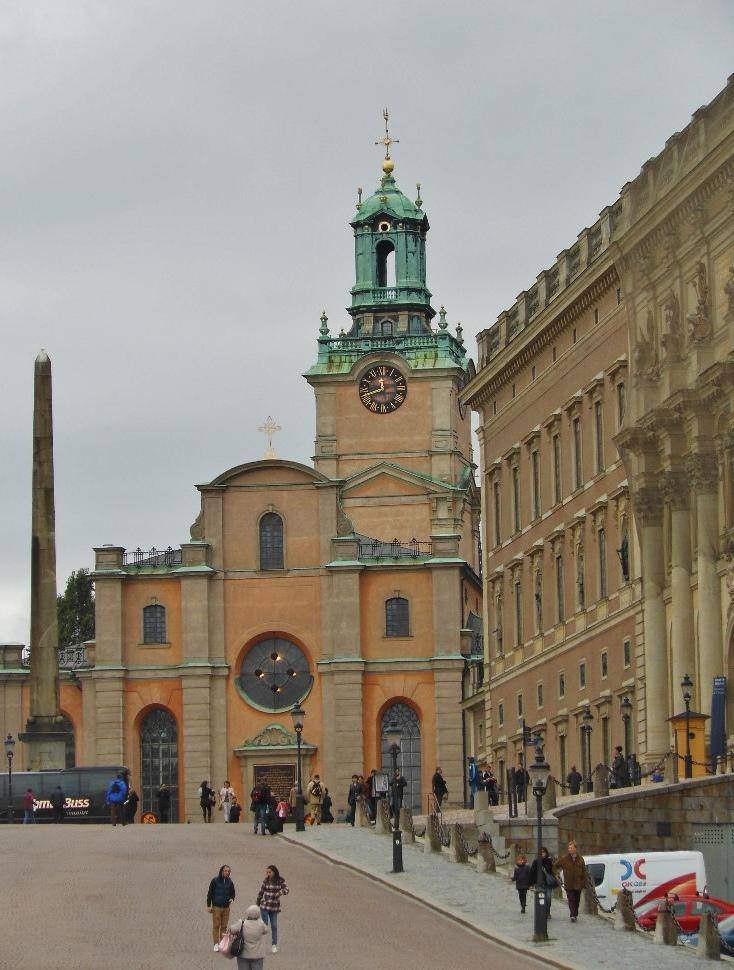Question: where are peoples walking?
Choices:
A. In the road.
B. In the grass.
C. Up the hill.
D. On the rocks.
Answer with the letter. Answer: A Question: why the clock is there in the building?
Choices:
A. For decoration.
B. For an alarm.
C. It's always been there.
D. To see time.
Answer with the letter. Answer: D Question: how the peoples are going?
Choices:
A. By walk.
B. By bus.
C. By car.
D. On a motorcycle.
Answer with the letter. Answer: A Question: what is cloudless?
Choices:
A. The sky.
B. The picture of the sky.
C. The photo of the sky.
D. The radar.
Answer with the letter. Answer: A Question: who are walking near the building?
Choices:
A. Pedestrians.
B. A pack of dogs.
C. A group of old people.
D. A group of kids.
Answer with the letter. Answer: A Question: what has roman numerals?
Choices:
A. A research paper.
B. On coins.
C. Math book.
D. The clock.
Answer with the letter. Answer: D Question: what type of day is it?
Choices:
A. It is sunny.
B. It is gloomy.
C. Overcast.
D. It is snowing.
Answer with the letter. Answer: C Question: what is on top of the building?
Choices:
A. A bird.
B. Godzilla.
C. Observatory.
D. A golden spire.
Answer with the letter. Answer: D Question: where is bus parked?
Choices:
A. In front of building on left.
B. By building on right.
C. Behind building on left.
D. Next to building on left.
Answer with the letter. Answer: D Question: where was this picture taken?
Choices:
A. At the horse races.
B. In a warehouse.
C. At a storage unit.
D. In front of building.
Answer with the letter. Answer: D Question: what time is it?
Choices:
A. It is near 10:00.
B. It is 4:00.
C. It is almost 11:45.
D. It is after 1:00.
Answer with the letter. Answer: C Question: what does the building on the right have?
Choices:
A. The building has white pillars.
B. It has many windows.
C. A Statue.
D. Shades.
Answer with the letter. Answer: A Question: what slopes downward?
Choices:
A. The street.
B. The hill.
C. The sidewalk.
D. The floor.
Answer with the letter. Answer: A 